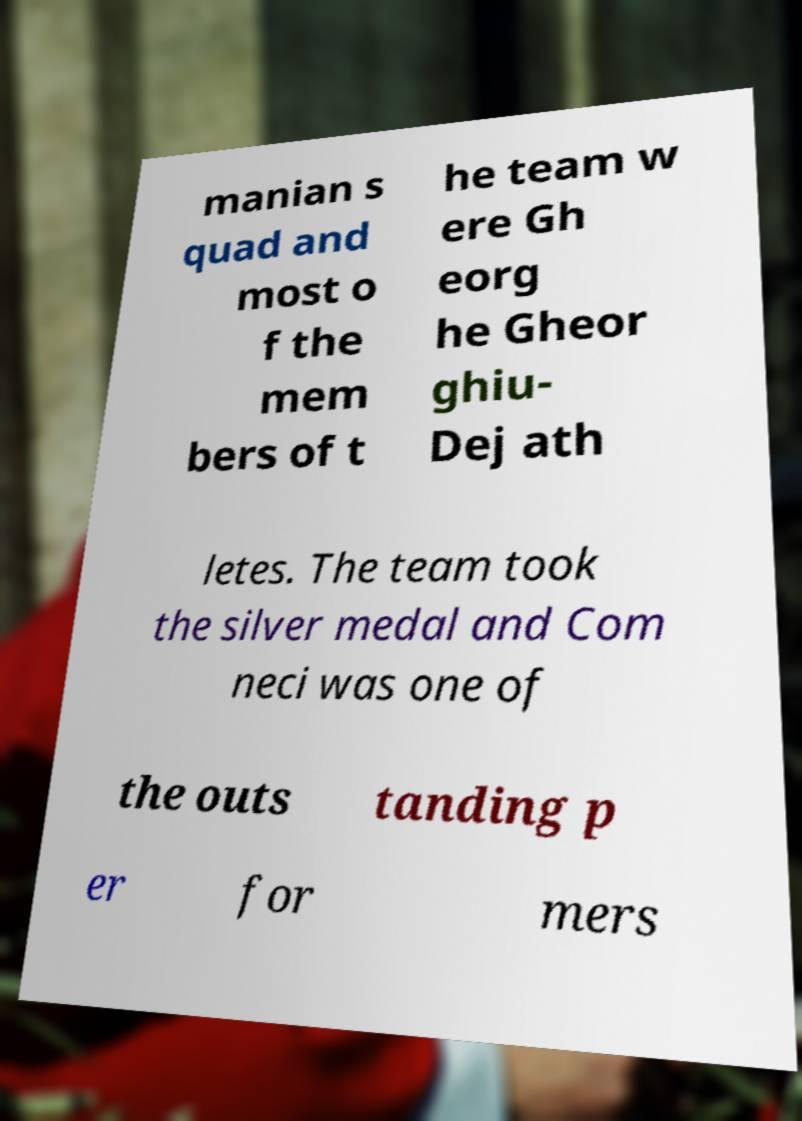Please read and relay the text visible in this image. What does it say? manian s quad and most o f the mem bers of t he team w ere Gh eorg he Gheor ghiu- Dej ath letes. The team took the silver medal and Com neci was one of the outs tanding p er for mers 